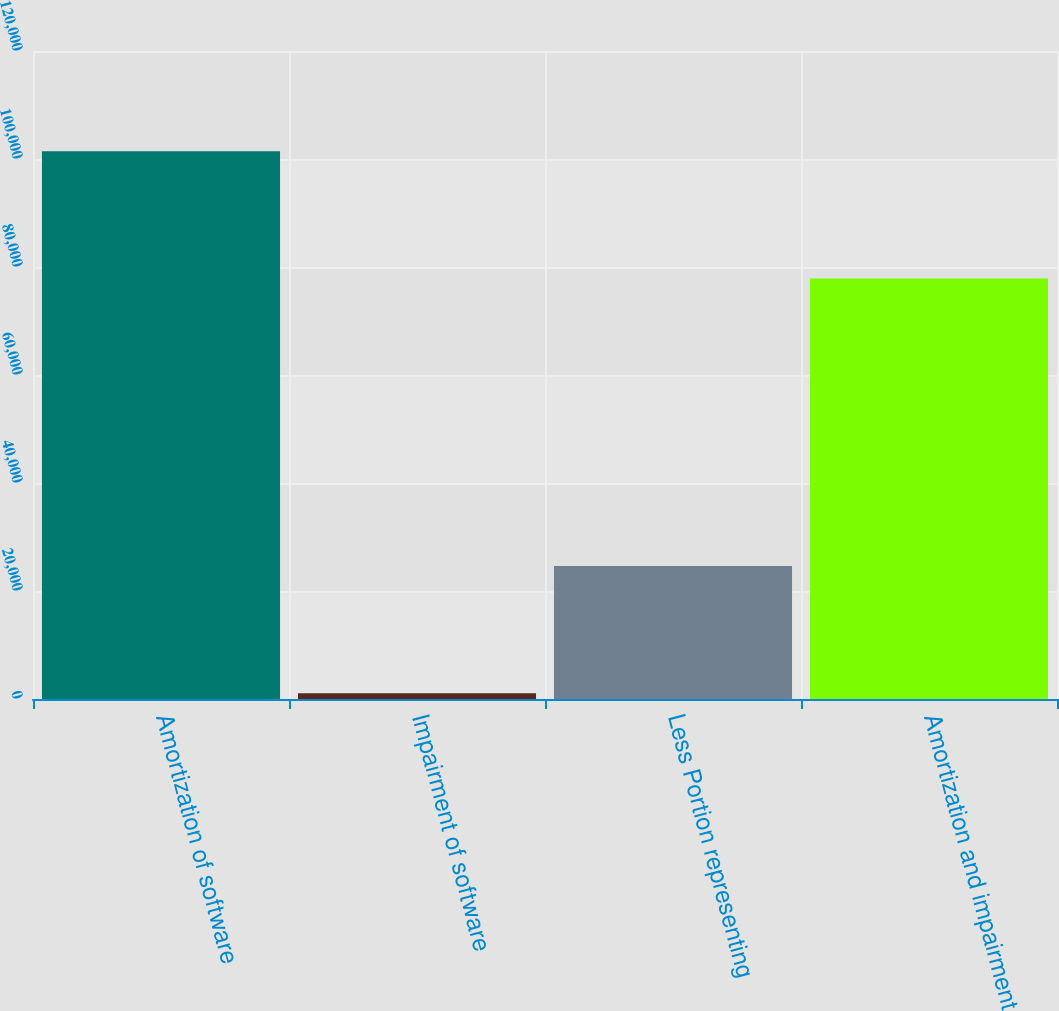Convert chart. <chart><loc_0><loc_0><loc_500><loc_500><bar_chart><fcel>Amortization of software<fcel>Impairment of software<fcel>Less Portion representing<fcel>Amortization and impairment<nl><fcel>101437<fcel>1060<fcel>24610<fcel>77887<nl></chart> 